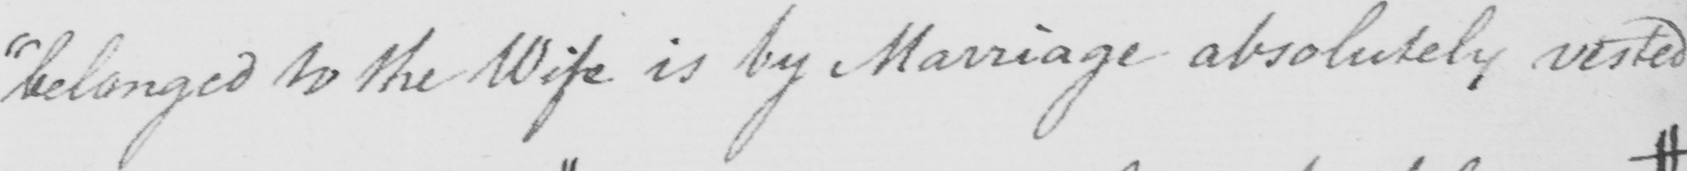What is written in this line of handwriting? " belonged to the Wife is by Marriage absolutely vested 